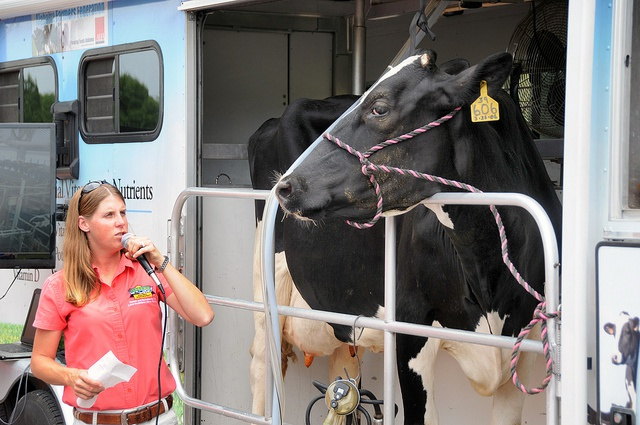Describe the objects in this image and their specific colors. I can see cow in lightgray, black, gray, and darkgray tones, people in lightgray and salmon tones, tv in lightgray, gray, and black tones, and tv in lightgray, white, gray, and darkgray tones in this image. 